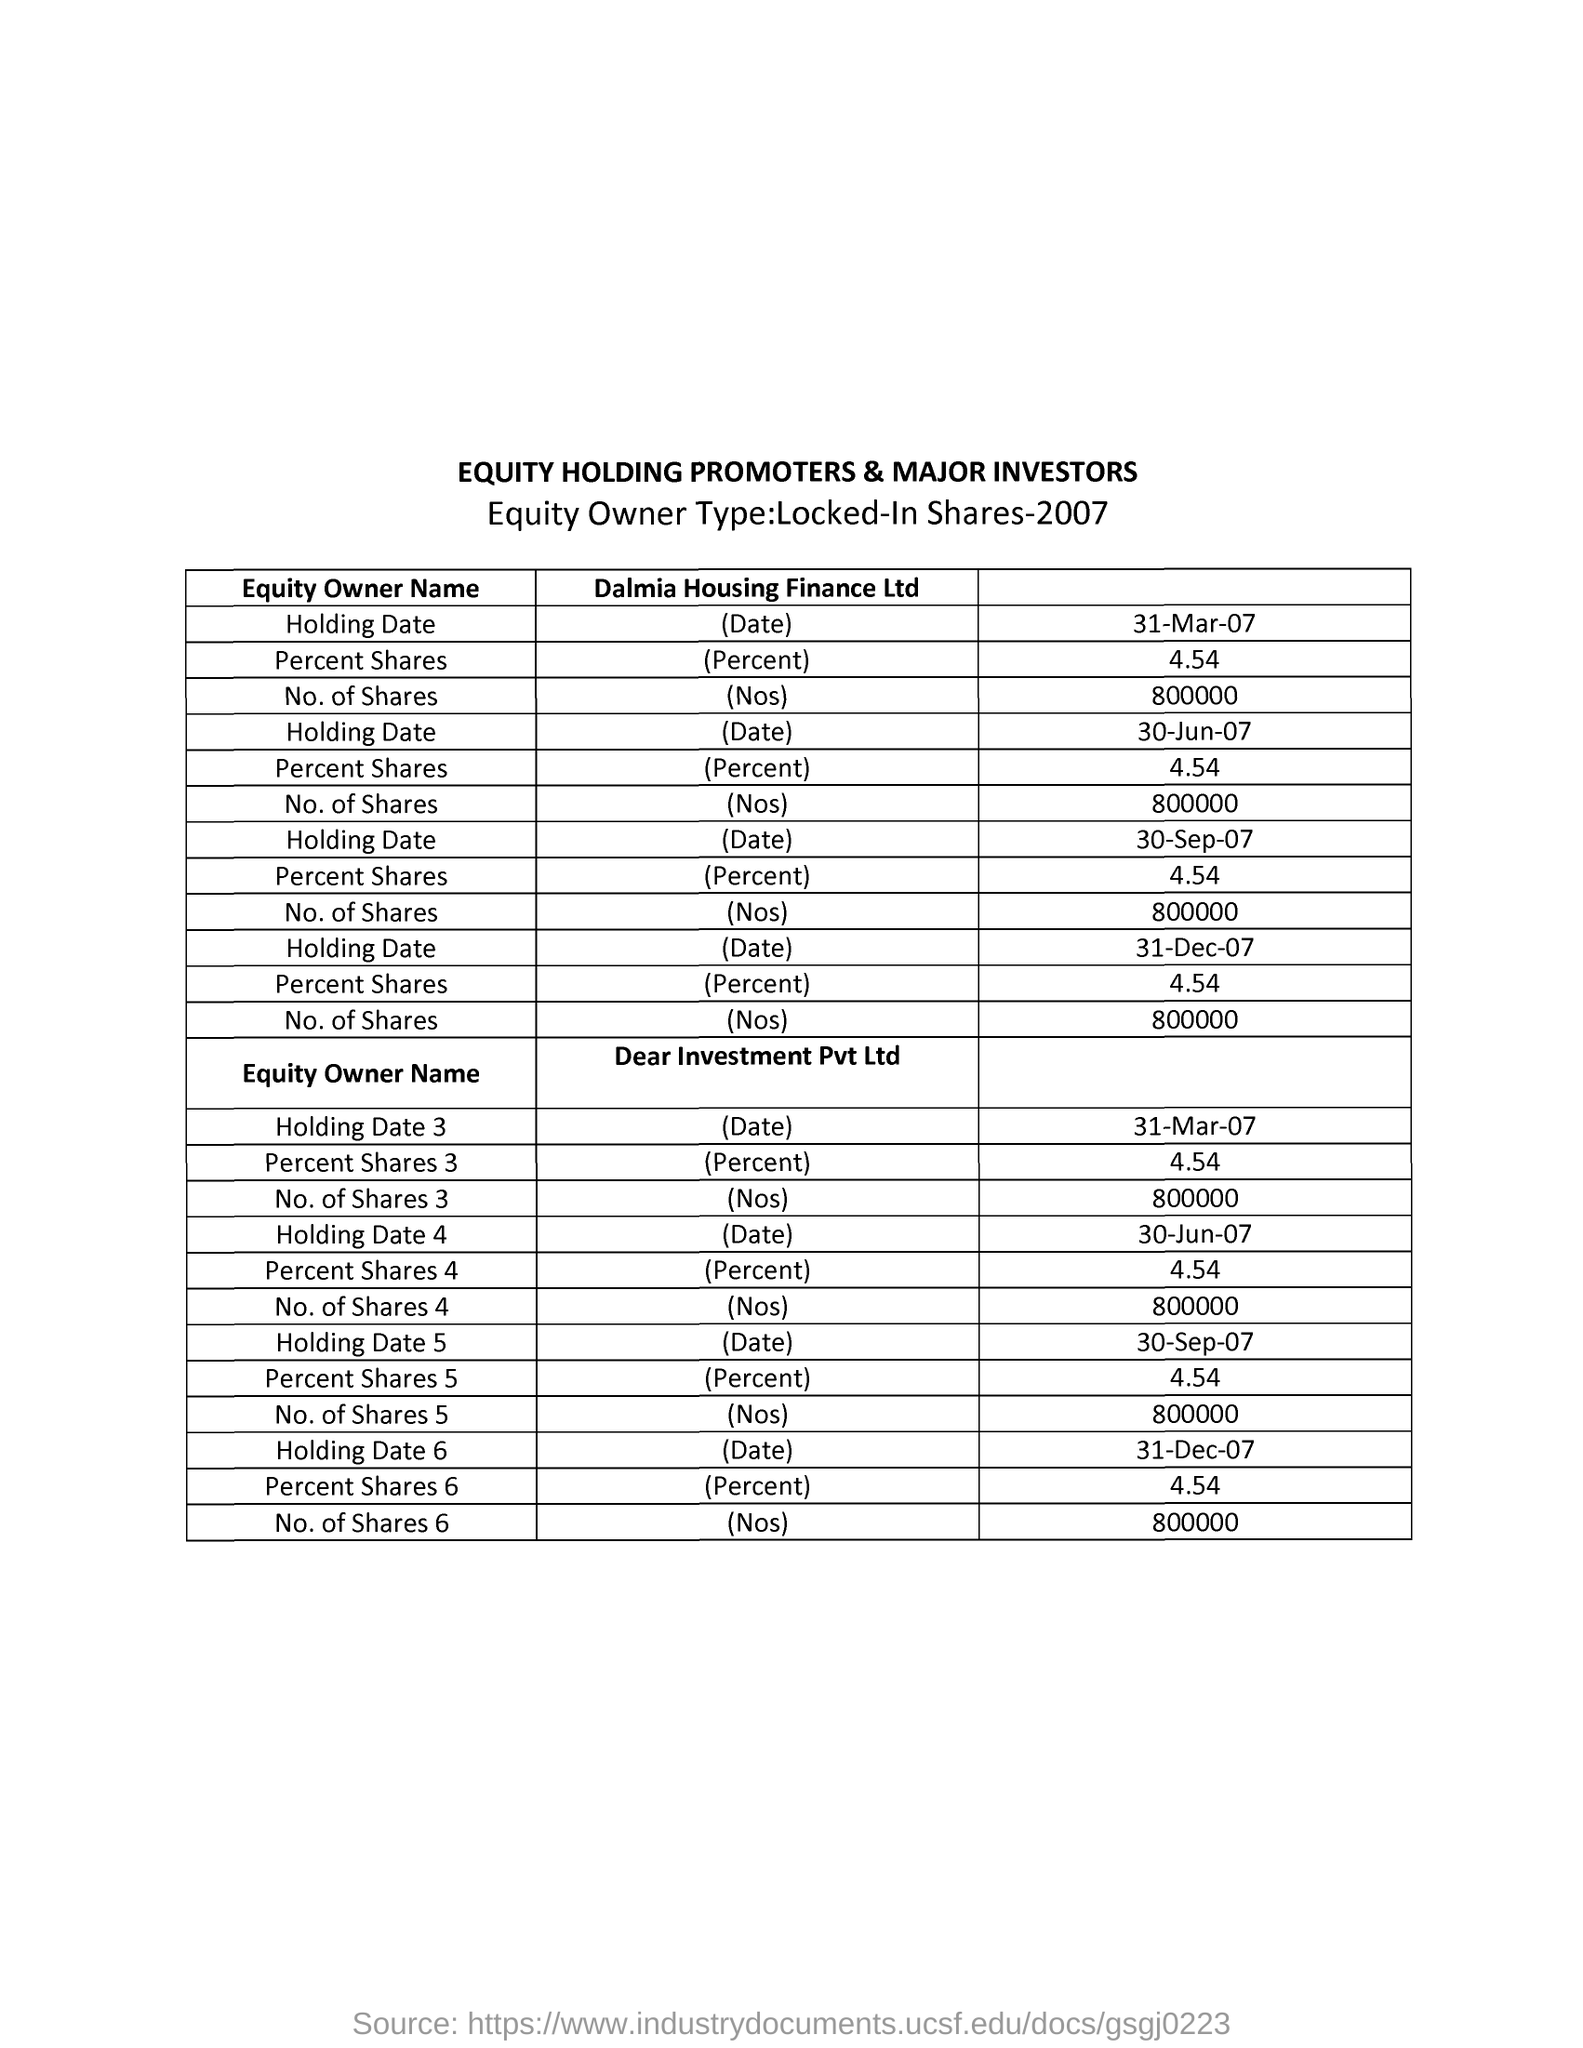What is the first title in the document?
Give a very brief answer. Equity Holding Promoters & Major Investors. 